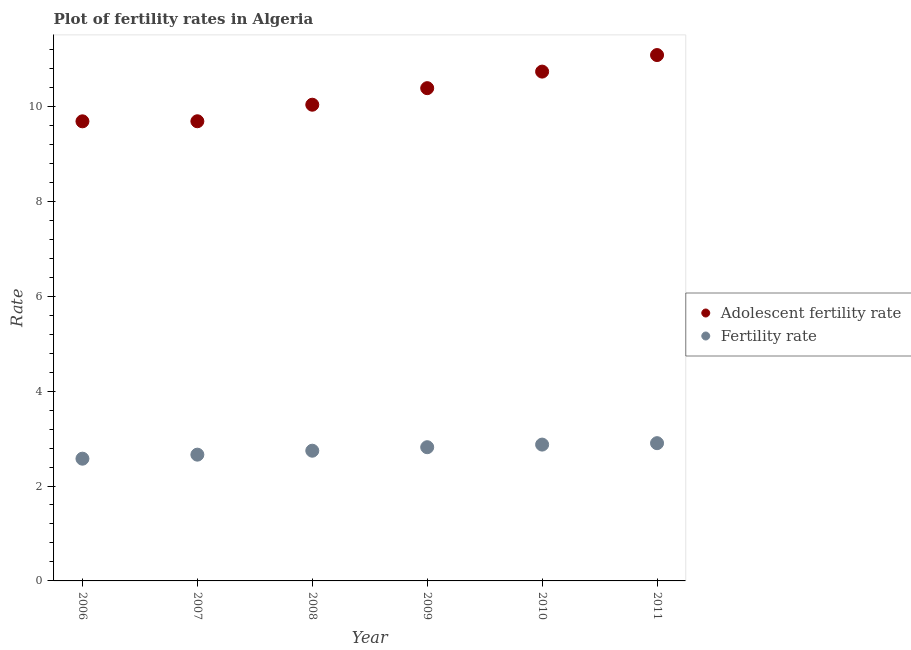Is the number of dotlines equal to the number of legend labels?
Provide a short and direct response. Yes. What is the adolescent fertility rate in 2007?
Ensure brevity in your answer.  9.69. Across all years, what is the maximum fertility rate?
Your answer should be very brief. 2.9. Across all years, what is the minimum adolescent fertility rate?
Offer a very short reply. 9.69. What is the total adolescent fertility rate in the graph?
Keep it short and to the point. 61.61. What is the difference between the adolescent fertility rate in 2008 and that in 2011?
Provide a succinct answer. -1.05. What is the difference between the adolescent fertility rate in 2007 and the fertility rate in 2006?
Make the answer very short. 7.11. What is the average adolescent fertility rate per year?
Give a very brief answer. 10.27. In the year 2011, what is the difference between the fertility rate and adolescent fertility rate?
Your response must be concise. -8.18. What is the ratio of the fertility rate in 2006 to that in 2009?
Offer a terse response. 0.91. Is the adolescent fertility rate in 2009 less than that in 2011?
Offer a terse response. Yes. Is the difference between the fertility rate in 2008 and 2010 greater than the difference between the adolescent fertility rate in 2008 and 2010?
Make the answer very short. Yes. What is the difference between the highest and the second highest adolescent fertility rate?
Make the answer very short. 0.35. What is the difference between the highest and the lowest fertility rate?
Offer a terse response. 0.33. In how many years, is the fertility rate greater than the average fertility rate taken over all years?
Give a very brief answer. 3. Is the sum of the fertility rate in 2010 and 2011 greater than the maximum adolescent fertility rate across all years?
Provide a short and direct response. No. Does the adolescent fertility rate monotonically increase over the years?
Provide a short and direct response. Yes. What is the difference between two consecutive major ticks on the Y-axis?
Offer a very short reply. 2. Are the values on the major ticks of Y-axis written in scientific E-notation?
Your answer should be very brief. No. What is the title of the graph?
Your response must be concise. Plot of fertility rates in Algeria. Does "Canada" appear as one of the legend labels in the graph?
Provide a short and direct response. No. What is the label or title of the Y-axis?
Make the answer very short. Rate. What is the Rate of Adolescent fertility rate in 2006?
Make the answer very short. 9.69. What is the Rate in Fertility rate in 2006?
Your answer should be compact. 2.58. What is the Rate of Adolescent fertility rate in 2007?
Make the answer very short. 9.69. What is the Rate in Fertility rate in 2007?
Provide a short and direct response. 2.66. What is the Rate in Adolescent fertility rate in 2008?
Give a very brief answer. 10.04. What is the Rate of Fertility rate in 2008?
Offer a terse response. 2.74. What is the Rate in Adolescent fertility rate in 2009?
Provide a short and direct response. 10.38. What is the Rate of Fertility rate in 2009?
Offer a terse response. 2.82. What is the Rate of Adolescent fertility rate in 2010?
Your answer should be compact. 10.73. What is the Rate in Fertility rate in 2010?
Offer a terse response. 2.87. What is the Rate of Adolescent fertility rate in 2011?
Ensure brevity in your answer.  11.08. What is the Rate of Fertility rate in 2011?
Ensure brevity in your answer.  2.9. Across all years, what is the maximum Rate of Adolescent fertility rate?
Your answer should be very brief. 11.08. Across all years, what is the maximum Rate of Fertility rate?
Offer a terse response. 2.9. Across all years, what is the minimum Rate in Adolescent fertility rate?
Provide a succinct answer. 9.69. Across all years, what is the minimum Rate in Fertility rate?
Ensure brevity in your answer.  2.58. What is the total Rate in Adolescent fertility rate in the graph?
Provide a succinct answer. 61.61. What is the total Rate in Fertility rate in the graph?
Keep it short and to the point. 16.57. What is the difference between the Rate in Adolescent fertility rate in 2006 and that in 2007?
Give a very brief answer. -0. What is the difference between the Rate in Fertility rate in 2006 and that in 2007?
Make the answer very short. -0.09. What is the difference between the Rate in Adolescent fertility rate in 2006 and that in 2008?
Keep it short and to the point. -0.35. What is the difference between the Rate of Fertility rate in 2006 and that in 2008?
Offer a very short reply. -0.17. What is the difference between the Rate of Adolescent fertility rate in 2006 and that in 2009?
Give a very brief answer. -0.7. What is the difference between the Rate in Fertility rate in 2006 and that in 2009?
Your response must be concise. -0.24. What is the difference between the Rate in Adolescent fertility rate in 2006 and that in 2010?
Provide a succinct answer. -1.05. What is the difference between the Rate in Fertility rate in 2006 and that in 2010?
Provide a succinct answer. -0.3. What is the difference between the Rate of Adolescent fertility rate in 2006 and that in 2011?
Keep it short and to the point. -1.4. What is the difference between the Rate in Fertility rate in 2006 and that in 2011?
Provide a succinct answer. -0.33. What is the difference between the Rate of Adolescent fertility rate in 2007 and that in 2008?
Offer a terse response. -0.35. What is the difference between the Rate of Fertility rate in 2007 and that in 2008?
Offer a terse response. -0.08. What is the difference between the Rate of Adolescent fertility rate in 2007 and that in 2009?
Your response must be concise. -0.7. What is the difference between the Rate of Fertility rate in 2007 and that in 2009?
Give a very brief answer. -0.16. What is the difference between the Rate of Adolescent fertility rate in 2007 and that in 2010?
Your response must be concise. -1.05. What is the difference between the Rate of Fertility rate in 2007 and that in 2010?
Offer a terse response. -0.21. What is the difference between the Rate of Adolescent fertility rate in 2007 and that in 2011?
Keep it short and to the point. -1.4. What is the difference between the Rate in Fertility rate in 2007 and that in 2011?
Offer a terse response. -0.24. What is the difference between the Rate of Adolescent fertility rate in 2008 and that in 2009?
Make the answer very short. -0.35. What is the difference between the Rate in Fertility rate in 2008 and that in 2009?
Offer a terse response. -0.07. What is the difference between the Rate of Adolescent fertility rate in 2008 and that in 2010?
Your response must be concise. -0.7. What is the difference between the Rate of Fertility rate in 2008 and that in 2010?
Give a very brief answer. -0.13. What is the difference between the Rate in Adolescent fertility rate in 2008 and that in 2011?
Offer a terse response. -1.05. What is the difference between the Rate in Fertility rate in 2008 and that in 2011?
Keep it short and to the point. -0.16. What is the difference between the Rate of Adolescent fertility rate in 2009 and that in 2010?
Offer a terse response. -0.35. What is the difference between the Rate of Fertility rate in 2009 and that in 2010?
Your response must be concise. -0.06. What is the difference between the Rate in Adolescent fertility rate in 2009 and that in 2011?
Your response must be concise. -0.7. What is the difference between the Rate of Fertility rate in 2009 and that in 2011?
Ensure brevity in your answer.  -0.09. What is the difference between the Rate of Adolescent fertility rate in 2010 and that in 2011?
Ensure brevity in your answer.  -0.35. What is the difference between the Rate in Fertility rate in 2010 and that in 2011?
Provide a short and direct response. -0.03. What is the difference between the Rate of Adolescent fertility rate in 2006 and the Rate of Fertility rate in 2007?
Your answer should be compact. 7.02. What is the difference between the Rate of Adolescent fertility rate in 2006 and the Rate of Fertility rate in 2008?
Provide a succinct answer. 6.94. What is the difference between the Rate in Adolescent fertility rate in 2006 and the Rate in Fertility rate in 2009?
Offer a terse response. 6.87. What is the difference between the Rate of Adolescent fertility rate in 2006 and the Rate of Fertility rate in 2010?
Provide a succinct answer. 6.81. What is the difference between the Rate of Adolescent fertility rate in 2006 and the Rate of Fertility rate in 2011?
Offer a terse response. 6.78. What is the difference between the Rate in Adolescent fertility rate in 2007 and the Rate in Fertility rate in 2008?
Ensure brevity in your answer.  6.94. What is the difference between the Rate of Adolescent fertility rate in 2007 and the Rate of Fertility rate in 2009?
Your answer should be very brief. 6.87. What is the difference between the Rate in Adolescent fertility rate in 2007 and the Rate in Fertility rate in 2010?
Your answer should be very brief. 6.81. What is the difference between the Rate of Adolescent fertility rate in 2007 and the Rate of Fertility rate in 2011?
Your response must be concise. 6.78. What is the difference between the Rate in Adolescent fertility rate in 2008 and the Rate in Fertility rate in 2009?
Your answer should be very brief. 7.22. What is the difference between the Rate in Adolescent fertility rate in 2008 and the Rate in Fertility rate in 2010?
Give a very brief answer. 7.16. What is the difference between the Rate in Adolescent fertility rate in 2008 and the Rate in Fertility rate in 2011?
Your response must be concise. 7.13. What is the difference between the Rate of Adolescent fertility rate in 2009 and the Rate of Fertility rate in 2010?
Offer a very short reply. 7.51. What is the difference between the Rate of Adolescent fertility rate in 2009 and the Rate of Fertility rate in 2011?
Your answer should be very brief. 7.48. What is the difference between the Rate in Adolescent fertility rate in 2010 and the Rate in Fertility rate in 2011?
Provide a succinct answer. 7.83. What is the average Rate of Adolescent fertility rate per year?
Offer a very short reply. 10.27. What is the average Rate of Fertility rate per year?
Ensure brevity in your answer.  2.76. In the year 2006, what is the difference between the Rate in Adolescent fertility rate and Rate in Fertility rate?
Your answer should be compact. 7.11. In the year 2007, what is the difference between the Rate in Adolescent fertility rate and Rate in Fertility rate?
Keep it short and to the point. 7.03. In the year 2008, what is the difference between the Rate of Adolescent fertility rate and Rate of Fertility rate?
Offer a terse response. 7.29. In the year 2009, what is the difference between the Rate in Adolescent fertility rate and Rate in Fertility rate?
Ensure brevity in your answer.  7.57. In the year 2010, what is the difference between the Rate of Adolescent fertility rate and Rate of Fertility rate?
Give a very brief answer. 7.86. In the year 2011, what is the difference between the Rate in Adolescent fertility rate and Rate in Fertility rate?
Your response must be concise. 8.18. What is the ratio of the Rate of Adolescent fertility rate in 2006 to that in 2007?
Your response must be concise. 1. What is the ratio of the Rate in Fertility rate in 2006 to that in 2007?
Offer a very short reply. 0.97. What is the ratio of the Rate in Adolescent fertility rate in 2006 to that in 2008?
Provide a short and direct response. 0.97. What is the ratio of the Rate in Fertility rate in 2006 to that in 2008?
Your answer should be very brief. 0.94. What is the ratio of the Rate of Adolescent fertility rate in 2006 to that in 2009?
Your answer should be compact. 0.93. What is the ratio of the Rate of Fertility rate in 2006 to that in 2009?
Your response must be concise. 0.91. What is the ratio of the Rate of Adolescent fertility rate in 2006 to that in 2010?
Offer a very short reply. 0.9. What is the ratio of the Rate in Fertility rate in 2006 to that in 2010?
Give a very brief answer. 0.9. What is the ratio of the Rate in Adolescent fertility rate in 2006 to that in 2011?
Provide a succinct answer. 0.87. What is the ratio of the Rate in Fertility rate in 2006 to that in 2011?
Your answer should be compact. 0.89. What is the ratio of the Rate of Adolescent fertility rate in 2007 to that in 2008?
Provide a succinct answer. 0.97. What is the ratio of the Rate in Fertility rate in 2007 to that in 2008?
Offer a terse response. 0.97. What is the ratio of the Rate in Adolescent fertility rate in 2007 to that in 2009?
Offer a terse response. 0.93. What is the ratio of the Rate in Fertility rate in 2007 to that in 2009?
Offer a terse response. 0.94. What is the ratio of the Rate of Adolescent fertility rate in 2007 to that in 2010?
Provide a succinct answer. 0.9. What is the ratio of the Rate of Fertility rate in 2007 to that in 2010?
Provide a short and direct response. 0.93. What is the ratio of the Rate in Adolescent fertility rate in 2007 to that in 2011?
Give a very brief answer. 0.87. What is the ratio of the Rate of Fertility rate in 2007 to that in 2011?
Give a very brief answer. 0.92. What is the ratio of the Rate of Adolescent fertility rate in 2008 to that in 2009?
Ensure brevity in your answer.  0.97. What is the ratio of the Rate in Fertility rate in 2008 to that in 2009?
Your answer should be very brief. 0.97. What is the ratio of the Rate of Adolescent fertility rate in 2008 to that in 2010?
Offer a very short reply. 0.94. What is the ratio of the Rate in Fertility rate in 2008 to that in 2010?
Your answer should be very brief. 0.96. What is the ratio of the Rate of Adolescent fertility rate in 2008 to that in 2011?
Ensure brevity in your answer.  0.91. What is the ratio of the Rate of Fertility rate in 2008 to that in 2011?
Offer a terse response. 0.95. What is the ratio of the Rate of Adolescent fertility rate in 2009 to that in 2010?
Ensure brevity in your answer.  0.97. What is the ratio of the Rate in Fertility rate in 2009 to that in 2010?
Your response must be concise. 0.98. What is the ratio of the Rate in Adolescent fertility rate in 2009 to that in 2011?
Ensure brevity in your answer.  0.94. What is the ratio of the Rate in Fertility rate in 2009 to that in 2011?
Your response must be concise. 0.97. What is the ratio of the Rate in Adolescent fertility rate in 2010 to that in 2011?
Your answer should be compact. 0.97. What is the difference between the highest and the second highest Rate of Adolescent fertility rate?
Ensure brevity in your answer.  0.35. What is the difference between the highest and the lowest Rate of Adolescent fertility rate?
Offer a terse response. 1.4. What is the difference between the highest and the lowest Rate in Fertility rate?
Make the answer very short. 0.33. 